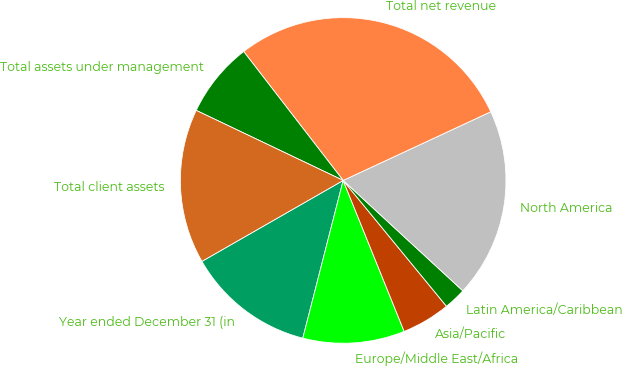Convert chart. <chart><loc_0><loc_0><loc_500><loc_500><pie_chart><fcel>Year ended December 31 (in<fcel>Europe/Middle East/Africa<fcel>Asia/Pacific<fcel>Latin America/Caribbean<fcel>North America<fcel>Total net revenue<fcel>Total assets under management<fcel>Total client assets<nl><fcel>12.73%<fcel>10.1%<fcel>4.83%<fcel>2.2%<fcel>18.79%<fcel>28.53%<fcel>7.46%<fcel>15.36%<nl></chart> 